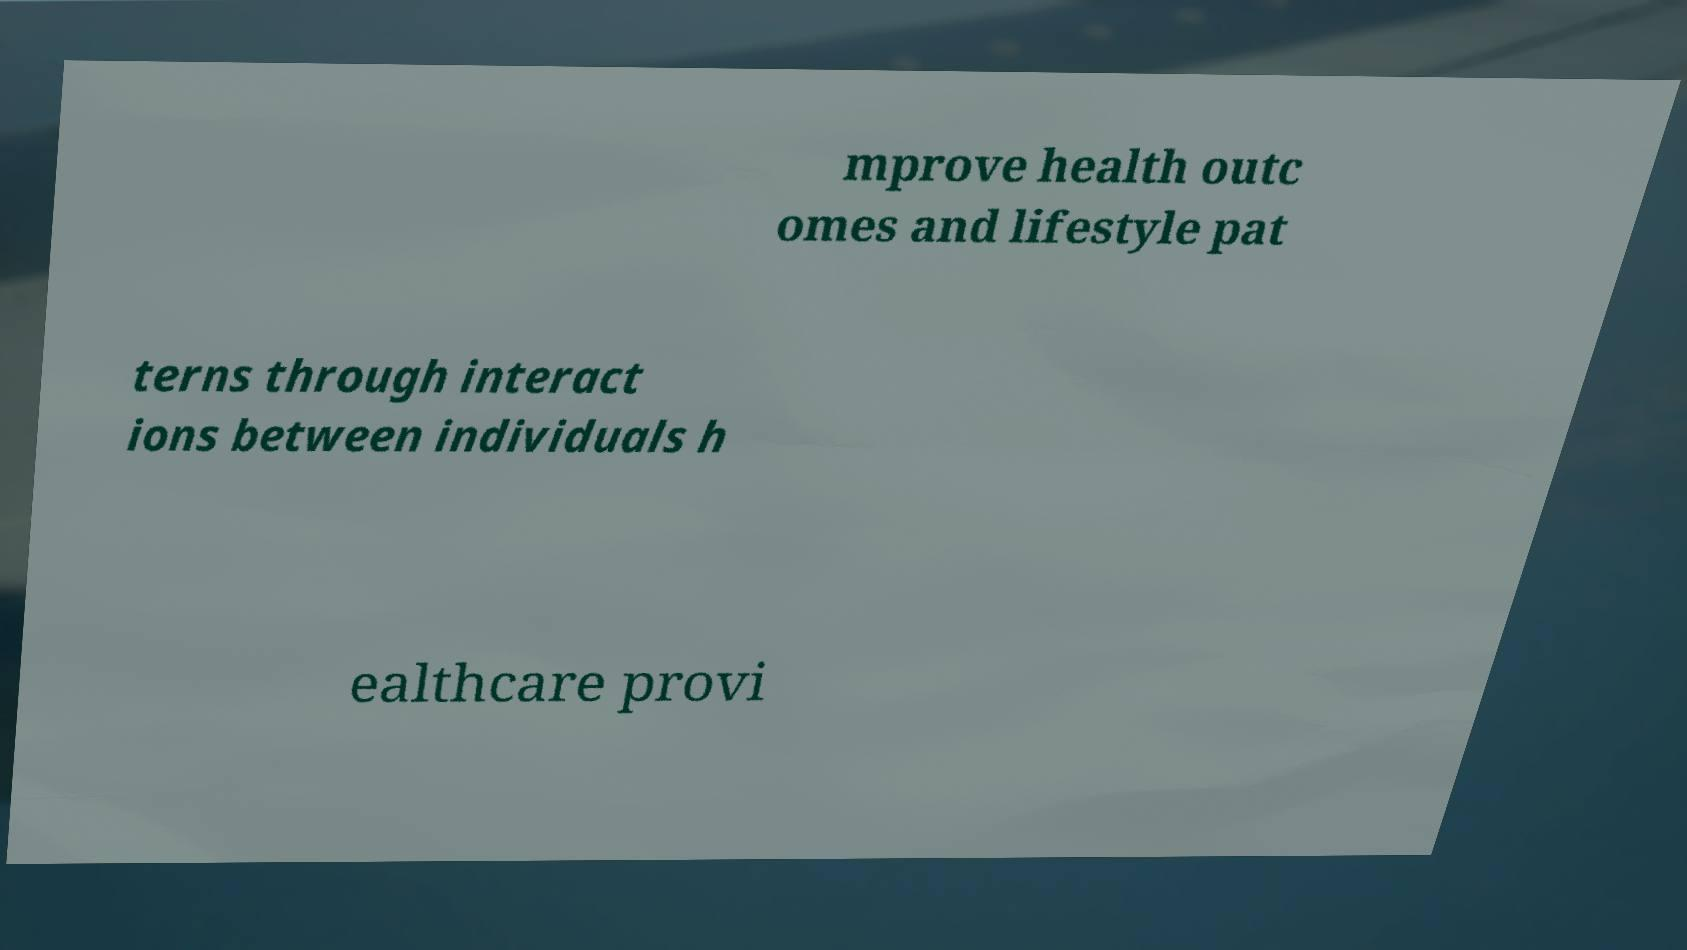I need the written content from this picture converted into text. Can you do that? mprove health outc omes and lifestyle pat terns through interact ions between individuals h ealthcare provi 